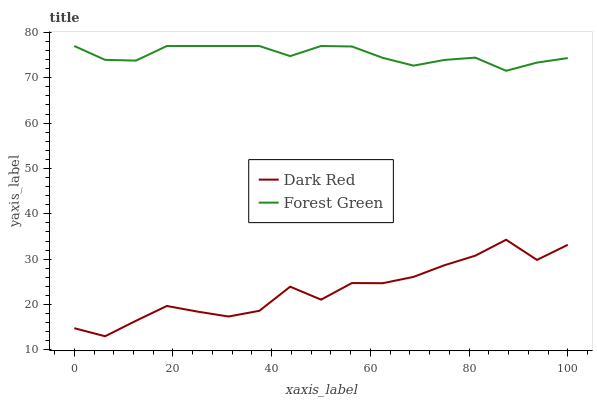Does Dark Red have the minimum area under the curve?
Answer yes or no. Yes. Does Forest Green have the maximum area under the curve?
Answer yes or no. Yes. Does Forest Green have the minimum area under the curve?
Answer yes or no. No. Is Forest Green the smoothest?
Answer yes or no. Yes. Is Dark Red the roughest?
Answer yes or no. Yes. Is Forest Green the roughest?
Answer yes or no. No. Does Dark Red have the lowest value?
Answer yes or no. Yes. Does Forest Green have the lowest value?
Answer yes or no. No. Does Forest Green have the highest value?
Answer yes or no. Yes. Is Dark Red less than Forest Green?
Answer yes or no. Yes. Is Forest Green greater than Dark Red?
Answer yes or no. Yes. Does Dark Red intersect Forest Green?
Answer yes or no. No. 